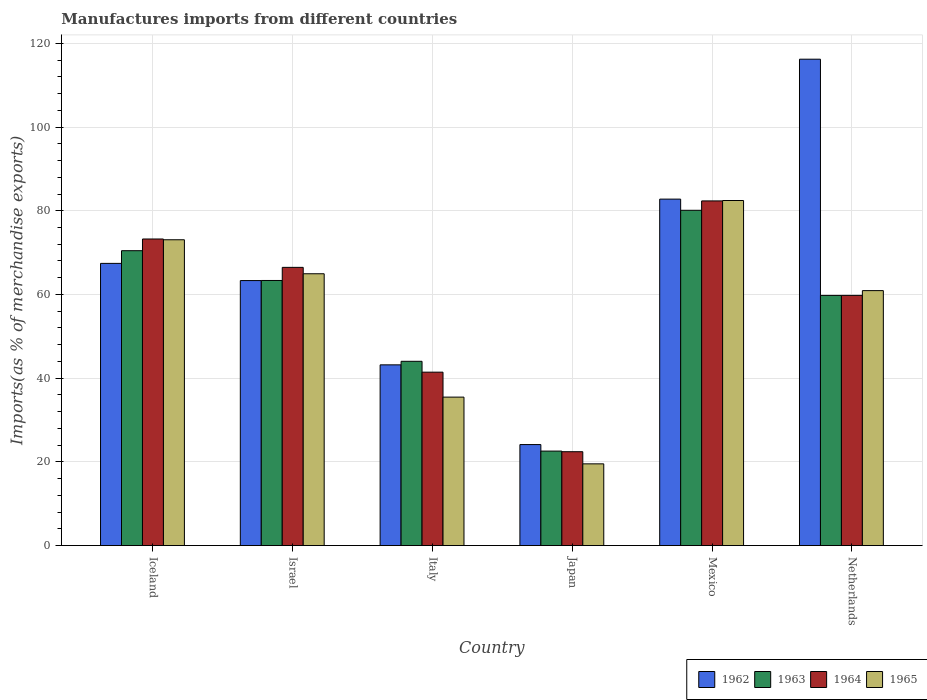How many bars are there on the 2nd tick from the left?
Make the answer very short. 4. In how many cases, is the number of bars for a given country not equal to the number of legend labels?
Your answer should be compact. 0. What is the percentage of imports to different countries in 1964 in Mexico?
Offer a terse response. 82.35. Across all countries, what is the maximum percentage of imports to different countries in 1963?
Provide a short and direct response. 80.11. Across all countries, what is the minimum percentage of imports to different countries in 1964?
Offer a very short reply. 22.43. In which country was the percentage of imports to different countries in 1964 maximum?
Make the answer very short. Mexico. In which country was the percentage of imports to different countries in 1963 minimum?
Your response must be concise. Japan. What is the total percentage of imports to different countries in 1965 in the graph?
Ensure brevity in your answer.  336.36. What is the difference between the percentage of imports to different countries in 1962 in Iceland and that in Israel?
Provide a short and direct response. 4.11. What is the difference between the percentage of imports to different countries in 1963 in Iceland and the percentage of imports to different countries in 1964 in Mexico?
Your answer should be compact. -11.9. What is the average percentage of imports to different countries in 1964 per country?
Offer a very short reply. 57.62. What is the difference between the percentage of imports to different countries of/in 1965 and percentage of imports to different countries of/in 1964 in Netherlands?
Offer a terse response. 1.14. In how many countries, is the percentage of imports to different countries in 1962 greater than 80 %?
Make the answer very short. 2. What is the ratio of the percentage of imports to different countries in 1965 in Iceland to that in Italy?
Make the answer very short. 2.06. Is the percentage of imports to different countries in 1963 in Italy less than that in Mexico?
Provide a succinct answer. Yes. What is the difference between the highest and the second highest percentage of imports to different countries in 1962?
Your answer should be compact. 15.35. What is the difference between the highest and the lowest percentage of imports to different countries in 1962?
Offer a very short reply. 92.08. In how many countries, is the percentage of imports to different countries in 1962 greater than the average percentage of imports to different countries in 1962 taken over all countries?
Give a very brief answer. 3. Is the sum of the percentage of imports to different countries in 1965 in Japan and Mexico greater than the maximum percentage of imports to different countries in 1964 across all countries?
Provide a short and direct response. Yes. What does the 3rd bar from the left in Japan represents?
Ensure brevity in your answer.  1964. What does the 1st bar from the right in Mexico represents?
Offer a terse response. 1965. How many bars are there?
Your answer should be compact. 24. Are all the bars in the graph horizontal?
Your answer should be very brief. No. What is the title of the graph?
Provide a short and direct response. Manufactures imports from different countries. Does "2000" appear as one of the legend labels in the graph?
Your response must be concise. No. What is the label or title of the Y-axis?
Keep it short and to the point. Imports(as % of merchandise exports). What is the Imports(as % of merchandise exports) in 1962 in Iceland?
Make the answer very short. 67.42. What is the Imports(as % of merchandise exports) in 1963 in Iceland?
Make the answer very short. 70.45. What is the Imports(as % of merchandise exports) in 1964 in Iceland?
Offer a very short reply. 73.25. What is the Imports(as % of merchandise exports) of 1965 in Iceland?
Your answer should be compact. 73.07. What is the Imports(as % of merchandise exports) in 1962 in Israel?
Offer a very short reply. 63.32. What is the Imports(as % of merchandise exports) in 1963 in Israel?
Give a very brief answer. 63.34. What is the Imports(as % of merchandise exports) in 1964 in Israel?
Ensure brevity in your answer.  66.47. What is the Imports(as % of merchandise exports) of 1965 in Israel?
Make the answer very short. 64.94. What is the Imports(as % of merchandise exports) of 1962 in Italy?
Provide a succinct answer. 43.18. What is the Imports(as % of merchandise exports) in 1963 in Italy?
Make the answer very short. 44.02. What is the Imports(as % of merchandise exports) in 1964 in Italy?
Make the answer very short. 41.43. What is the Imports(as % of merchandise exports) of 1965 in Italy?
Offer a very short reply. 35.47. What is the Imports(as % of merchandise exports) in 1962 in Japan?
Your response must be concise. 24.13. What is the Imports(as % of merchandise exports) of 1963 in Japan?
Your answer should be compact. 22.57. What is the Imports(as % of merchandise exports) of 1964 in Japan?
Keep it short and to the point. 22.43. What is the Imports(as % of merchandise exports) of 1965 in Japan?
Your answer should be very brief. 19.52. What is the Imports(as % of merchandise exports) in 1962 in Mexico?
Give a very brief answer. 82.78. What is the Imports(as % of merchandise exports) in 1963 in Mexico?
Your answer should be very brief. 80.11. What is the Imports(as % of merchandise exports) in 1964 in Mexico?
Ensure brevity in your answer.  82.35. What is the Imports(as % of merchandise exports) of 1965 in Mexico?
Your response must be concise. 82.44. What is the Imports(as % of merchandise exports) of 1962 in Netherlands?
Offer a very short reply. 116.21. What is the Imports(as % of merchandise exports) of 1963 in Netherlands?
Your response must be concise. 59.77. What is the Imports(as % of merchandise exports) of 1964 in Netherlands?
Your answer should be very brief. 59.78. What is the Imports(as % of merchandise exports) of 1965 in Netherlands?
Offer a terse response. 60.91. Across all countries, what is the maximum Imports(as % of merchandise exports) in 1962?
Keep it short and to the point. 116.21. Across all countries, what is the maximum Imports(as % of merchandise exports) of 1963?
Your response must be concise. 80.11. Across all countries, what is the maximum Imports(as % of merchandise exports) of 1964?
Keep it short and to the point. 82.35. Across all countries, what is the maximum Imports(as % of merchandise exports) of 1965?
Make the answer very short. 82.44. Across all countries, what is the minimum Imports(as % of merchandise exports) of 1962?
Make the answer very short. 24.13. Across all countries, what is the minimum Imports(as % of merchandise exports) of 1963?
Ensure brevity in your answer.  22.57. Across all countries, what is the minimum Imports(as % of merchandise exports) in 1964?
Offer a very short reply. 22.43. Across all countries, what is the minimum Imports(as % of merchandise exports) in 1965?
Make the answer very short. 19.52. What is the total Imports(as % of merchandise exports) in 1962 in the graph?
Keep it short and to the point. 397.04. What is the total Imports(as % of merchandise exports) in 1963 in the graph?
Your response must be concise. 340.27. What is the total Imports(as % of merchandise exports) of 1964 in the graph?
Your response must be concise. 345.71. What is the total Imports(as % of merchandise exports) in 1965 in the graph?
Your response must be concise. 336.36. What is the difference between the Imports(as % of merchandise exports) of 1962 in Iceland and that in Israel?
Your answer should be compact. 4.11. What is the difference between the Imports(as % of merchandise exports) in 1963 in Iceland and that in Israel?
Offer a very short reply. 7.11. What is the difference between the Imports(as % of merchandise exports) in 1964 in Iceland and that in Israel?
Keep it short and to the point. 6.78. What is the difference between the Imports(as % of merchandise exports) of 1965 in Iceland and that in Israel?
Offer a very short reply. 8.12. What is the difference between the Imports(as % of merchandise exports) of 1962 in Iceland and that in Italy?
Provide a short and direct response. 24.24. What is the difference between the Imports(as % of merchandise exports) of 1963 in Iceland and that in Italy?
Provide a succinct answer. 26.43. What is the difference between the Imports(as % of merchandise exports) in 1964 in Iceland and that in Italy?
Provide a short and direct response. 31.82. What is the difference between the Imports(as % of merchandise exports) in 1965 in Iceland and that in Italy?
Provide a short and direct response. 37.6. What is the difference between the Imports(as % of merchandise exports) of 1962 in Iceland and that in Japan?
Keep it short and to the point. 43.29. What is the difference between the Imports(as % of merchandise exports) in 1963 in Iceland and that in Japan?
Your response must be concise. 47.88. What is the difference between the Imports(as % of merchandise exports) in 1964 in Iceland and that in Japan?
Your answer should be compact. 50.82. What is the difference between the Imports(as % of merchandise exports) in 1965 in Iceland and that in Japan?
Provide a succinct answer. 53.54. What is the difference between the Imports(as % of merchandise exports) in 1962 in Iceland and that in Mexico?
Ensure brevity in your answer.  -15.35. What is the difference between the Imports(as % of merchandise exports) in 1963 in Iceland and that in Mexico?
Provide a succinct answer. -9.65. What is the difference between the Imports(as % of merchandise exports) in 1964 in Iceland and that in Mexico?
Give a very brief answer. -9.1. What is the difference between the Imports(as % of merchandise exports) in 1965 in Iceland and that in Mexico?
Make the answer very short. -9.38. What is the difference between the Imports(as % of merchandise exports) in 1962 in Iceland and that in Netherlands?
Give a very brief answer. -48.79. What is the difference between the Imports(as % of merchandise exports) in 1963 in Iceland and that in Netherlands?
Keep it short and to the point. 10.68. What is the difference between the Imports(as % of merchandise exports) in 1964 in Iceland and that in Netherlands?
Your answer should be very brief. 13.47. What is the difference between the Imports(as % of merchandise exports) of 1965 in Iceland and that in Netherlands?
Your answer should be very brief. 12.15. What is the difference between the Imports(as % of merchandise exports) of 1962 in Israel and that in Italy?
Provide a short and direct response. 20.14. What is the difference between the Imports(as % of merchandise exports) of 1963 in Israel and that in Italy?
Make the answer very short. 19.32. What is the difference between the Imports(as % of merchandise exports) of 1964 in Israel and that in Italy?
Your answer should be compact. 25.04. What is the difference between the Imports(as % of merchandise exports) of 1965 in Israel and that in Italy?
Give a very brief answer. 29.47. What is the difference between the Imports(as % of merchandise exports) in 1962 in Israel and that in Japan?
Ensure brevity in your answer.  39.19. What is the difference between the Imports(as % of merchandise exports) in 1963 in Israel and that in Japan?
Offer a very short reply. 40.77. What is the difference between the Imports(as % of merchandise exports) of 1964 in Israel and that in Japan?
Your response must be concise. 44.04. What is the difference between the Imports(as % of merchandise exports) in 1965 in Israel and that in Japan?
Provide a succinct answer. 45.42. What is the difference between the Imports(as % of merchandise exports) of 1962 in Israel and that in Mexico?
Ensure brevity in your answer.  -19.46. What is the difference between the Imports(as % of merchandise exports) of 1963 in Israel and that in Mexico?
Your answer should be very brief. -16.77. What is the difference between the Imports(as % of merchandise exports) in 1964 in Israel and that in Mexico?
Provide a short and direct response. -15.88. What is the difference between the Imports(as % of merchandise exports) in 1965 in Israel and that in Mexico?
Keep it short and to the point. -17.5. What is the difference between the Imports(as % of merchandise exports) in 1962 in Israel and that in Netherlands?
Ensure brevity in your answer.  -52.9. What is the difference between the Imports(as % of merchandise exports) in 1963 in Israel and that in Netherlands?
Provide a short and direct response. 3.57. What is the difference between the Imports(as % of merchandise exports) in 1964 in Israel and that in Netherlands?
Offer a terse response. 6.69. What is the difference between the Imports(as % of merchandise exports) in 1965 in Israel and that in Netherlands?
Your answer should be very brief. 4.03. What is the difference between the Imports(as % of merchandise exports) in 1962 in Italy and that in Japan?
Offer a terse response. 19.05. What is the difference between the Imports(as % of merchandise exports) in 1963 in Italy and that in Japan?
Your answer should be very brief. 21.45. What is the difference between the Imports(as % of merchandise exports) in 1964 in Italy and that in Japan?
Offer a very short reply. 19. What is the difference between the Imports(as % of merchandise exports) in 1965 in Italy and that in Japan?
Offer a terse response. 15.94. What is the difference between the Imports(as % of merchandise exports) in 1962 in Italy and that in Mexico?
Offer a terse response. -39.6. What is the difference between the Imports(as % of merchandise exports) in 1963 in Italy and that in Mexico?
Give a very brief answer. -36.08. What is the difference between the Imports(as % of merchandise exports) in 1964 in Italy and that in Mexico?
Provide a succinct answer. -40.92. What is the difference between the Imports(as % of merchandise exports) of 1965 in Italy and that in Mexico?
Provide a succinct answer. -46.98. What is the difference between the Imports(as % of merchandise exports) of 1962 in Italy and that in Netherlands?
Ensure brevity in your answer.  -73.03. What is the difference between the Imports(as % of merchandise exports) in 1963 in Italy and that in Netherlands?
Your answer should be compact. -15.75. What is the difference between the Imports(as % of merchandise exports) of 1964 in Italy and that in Netherlands?
Provide a succinct answer. -18.35. What is the difference between the Imports(as % of merchandise exports) of 1965 in Italy and that in Netherlands?
Offer a terse response. -25.45. What is the difference between the Imports(as % of merchandise exports) of 1962 in Japan and that in Mexico?
Provide a short and direct response. -58.65. What is the difference between the Imports(as % of merchandise exports) of 1963 in Japan and that in Mexico?
Your response must be concise. -57.53. What is the difference between the Imports(as % of merchandise exports) of 1964 in Japan and that in Mexico?
Your response must be concise. -59.92. What is the difference between the Imports(as % of merchandise exports) in 1965 in Japan and that in Mexico?
Your response must be concise. -62.92. What is the difference between the Imports(as % of merchandise exports) in 1962 in Japan and that in Netherlands?
Make the answer very short. -92.08. What is the difference between the Imports(as % of merchandise exports) of 1963 in Japan and that in Netherlands?
Offer a terse response. -37.2. What is the difference between the Imports(as % of merchandise exports) of 1964 in Japan and that in Netherlands?
Ensure brevity in your answer.  -37.35. What is the difference between the Imports(as % of merchandise exports) of 1965 in Japan and that in Netherlands?
Your answer should be compact. -41.39. What is the difference between the Imports(as % of merchandise exports) of 1962 in Mexico and that in Netherlands?
Provide a succinct answer. -33.43. What is the difference between the Imports(as % of merchandise exports) in 1963 in Mexico and that in Netherlands?
Provide a short and direct response. 20.34. What is the difference between the Imports(as % of merchandise exports) in 1964 in Mexico and that in Netherlands?
Provide a short and direct response. 22.57. What is the difference between the Imports(as % of merchandise exports) of 1965 in Mexico and that in Netherlands?
Offer a terse response. 21.53. What is the difference between the Imports(as % of merchandise exports) of 1962 in Iceland and the Imports(as % of merchandise exports) of 1963 in Israel?
Keep it short and to the point. 4.08. What is the difference between the Imports(as % of merchandise exports) in 1962 in Iceland and the Imports(as % of merchandise exports) in 1964 in Israel?
Give a very brief answer. 0.95. What is the difference between the Imports(as % of merchandise exports) of 1962 in Iceland and the Imports(as % of merchandise exports) of 1965 in Israel?
Provide a succinct answer. 2.48. What is the difference between the Imports(as % of merchandise exports) of 1963 in Iceland and the Imports(as % of merchandise exports) of 1964 in Israel?
Your response must be concise. 3.98. What is the difference between the Imports(as % of merchandise exports) in 1963 in Iceland and the Imports(as % of merchandise exports) in 1965 in Israel?
Give a very brief answer. 5.51. What is the difference between the Imports(as % of merchandise exports) in 1964 in Iceland and the Imports(as % of merchandise exports) in 1965 in Israel?
Offer a very short reply. 8.31. What is the difference between the Imports(as % of merchandise exports) of 1962 in Iceland and the Imports(as % of merchandise exports) of 1963 in Italy?
Your response must be concise. 23.4. What is the difference between the Imports(as % of merchandise exports) of 1962 in Iceland and the Imports(as % of merchandise exports) of 1964 in Italy?
Provide a succinct answer. 25.99. What is the difference between the Imports(as % of merchandise exports) in 1962 in Iceland and the Imports(as % of merchandise exports) in 1965 in Italy?
Offer a terse response. 31.95. What is the difference between the Imports(as % of merchandise exports) of 1963 in Iceland and the Imports(as % of merchandise exports) of 1964 in Italy?
Provide a succinct answer. 29.02. What is the difference between the Imports(as % of merchandise exports) in 1963 in Iceland and the Imports(as % of merchandise exports) in 1965 in Italy?
Ensure brevity in your answer.  34.99. What is the difference between the Imports(as % of merchandise exports) of 1964 in Iceland and the Imports(as % of merchandise exports) of 1965 in Italy?
Your answer should be compact. 37.78. What is the difference between the Imports(as % of merchandise exports) of 1962 in Iceland and the Imports(as % of merchandise exports) of 1963 in Japan?
Your answer should be compact. 44.85. What is the difference between the Imports(as % of merchandise exports) in 1962 in Iceland and the Imports(as % of merchandise exports) in 1964 in Japan?
Offer a very short reply. 45. What is the difference between the Imports(as % of merchandise exports) in 1962 in Iceland and the Imports(as % of merchandise exports) in 1965 in Japan?
Make the answer very short. 47.9. What is the difference between the Imports(as % of merchandise exports) of 1963 in Iceland and the Imports(as % of merchandise exports) of 1964 in Japan?
Your response must be concise. 48.03. What is the difference between the Imports(as % of merchandise exports) in 1963 in Iceland and the Imports(as % of merchandise exports) in 1965 in Japan?
Your answer should be very brief. 50.93. What is the difference between the Imports(as % of merchandise exports) of 1964 in Iceland and the Imports(as % of merchandise exports) of 1965 in Japan?
Provide a succinct answer. 53.73. What is the difference between the Imports(as % of merchandise exports) in 1962 in Iceland and the Imports(as % of merchandise exports) in 1963 in Mexico?
Provide a short and direct response. -12.68. What is the difference between the Imports(as % of merchandise exports) in 1962 in Iceland and the Imports(as % of merchandise exports) in 1964 in Mexico?
Provide a short and direct response. -14.93. What is the difference between the Imports(as % of merchandise exports) of 1962 in Iceland and the Imports(as % of merchandise exports) of 1965 in Mexico?
Keep it short and to the point. -15.02. What is the difference between the Imports(as % of merchandise exports) in 1963 in Iceland and the Imports(as % of merchandise exports) in 1964 in Mexico?
Offer a terse response. -11.9. What is the difference between the Imports(as % of merchandise exports) in 1963 in Iceland and the Imports(as % of merchandise exports) in 1965 in Mexico?
Provide a short and direct response. -11.99. What is the difference between the Imports(as % of merchandise exports) of 1964 in Iceland and the Imports(as % of merchandise exports) of 1965 in Mexico?
Ensure brevity in your answer.  -9.19. What is the difference between the Imports(as % of merchandise exports) in 1962 in Iceland and the Imports(as % of merchandise exports) in 1963 in Netherlands?
Provide a succinct answer. 7.65. What is the difference between the Imports(as % of merchandise exports) in 1962 in Iceland and the Imports(as % of merchandise exports) in 1964 in Netherlands?
Provide a succinct answer. 7.64. What is the difference between the Imports(as % of merchandise exports) in 1962 in Iceland and the Imports(as % of merchandise exports) in 1965 in Netherlands?
Provide a short and direct response. 6.51. What is the difference between the Imports(as % of merchandise exports) of 1963 in Iceland and the Imports(as % of merchandise exports) of 1964 in Netherlands?
Give a very brief answer. 10.68. What is the difference between the Imports(as % of merchandise exports) in 1963 in Iceland and the Imports(as % of merchandise exports) in 1965 in Netherlands?
Ensure brevity in your answer.  9.54. What is the difference between the Imports(as % of merchandise exports) in 1964 in Iceland and the Imports(as % of merchandise exports) in 1965 in Netherlands?
Ensure brevity in your answer.  12.34. What is the difference between the Imports(as % of merchandise exports) in 1962 in Israel and the Imports(as % of merchandise exports) in 1963 in Italy?
Provide a short and direct response. 19.29. What is the difference between the Imports(as % of merchandise exports) in 1962 in Israel and the Imports(as % of merchandise exports) in 1964 in Italy?
Provide a succinct answer. 21.88. What is the difference between the Imports(as % of merchandise exports) of 1962 in Israel and the Imports(as % of merchandise exports) of 1965 in Italy?
Offer a terse response. 27.85. What is the difference between the Imports(as % of merchandise exports) in 1963 in Israel and the Imports(as % of merchandise exports) in 1964 in Italy?
Make the answer very short. 21.91. What is the difference between the Imports(as % of merchandise exports) in 1963 in Israel and the Imports(as % of merchandise exports) in 1965 in Italy?
Keep it short and to the point. 27.87. What is the difference between the Imports(as % of merchandise exports) in 1964 in Israel and the Imports(as % of merchandise exports) in 1965 in Italy?
Provide a succinct answer. 31. What is the difference between the Imports(as % of merchandise exports) in 1962 in Israel and the Imports(as % of merchandise exports) in 1963 in Japan?
Offer a terse response. 40.74. What is the difference between the Imports(as % of merchandise exports) in 1962 in Israel and the Imports(as % of merchandise exports) in 1964 in Japan?
Your answer should be compact. 40.89. What is the difference between the Imports(as % of merchandise exports) of 1962 in Israel and the Imports(as % of merchandise exports) of 1965 in Japan?
Provide a short and direct response. 43.79. What is the difference between the Imports(as % of merchandise exports) in 1963 in Israel and the Imports(as % of merchandise exports) in 1964 in Japan?
Offer a terse response. 40.91. What is the difference between the Imports(as % of merchandise exports) of 1963 in Israel and the Imports(as % of merchandise exports) of 1965 in Japan?
Your response must be concise. 43.82. What is the difference between the Imports(as % of merchandise exports) in 1964 in Israel and the Imports(as % of merchandise exports) in 1965 in Japan?
Keep it short and to the point. 46.94. What is the difference between the Imports(as % of merchandise exports) in 1962 in Israel and the Imports(as % of merchandise exports) in 1963 in Mexico?
Offer a very short reply. -16.79. What is the difference between the Imports(as % of merchandise exports) of 1962 in Israel and the Imports(as % of merchandise exports) of 1964 in Mexico?
Offer a terse response. -19.03. What is the difference between the Imports(as % of merchandise exports) of 1962 in Israel and the Imports(as % of merchandise exports) of 1965 in Mexico?
Offer a terse response. -19.13. What is the difference between the Imports(as % of merchandise exports) in 1963 in Israel and the Imports(as % of merchandise exports) in 1964 in Mexico?
Offer a very short reply. -19.01. What is the difference between the Imports(as % of merchandise exports) in 1963 in Israel and the Imports(as % of merchandise exports) in 1965 in Mexico?
Your answer should be compact. -19.1. What is the difference between the Imports(as % of merchandise exports) of 1964 in Israel and the Imports(as % of merchandise exports) of 1965 in Mexico?
Provide a succinct answer. -15.98. What is the difference between the Imports(as % of merchandise exports) in 1962 in Israel and the Imports(as % of merchandise exports) in 1963 in Netherlands?
Give a very brief answer. 3.54. What is the difference between the Imports(as % of merchandise exports) of 1962 in Israel and the Imports(as % of merchandise exports) of 1964 in Netherlands?
Your response must be concise. 3.54. What is the difference between the Imports(as % of merchandise exports) of 1962 in Israel and the Imports(as % of merchandise exports) of 1965 in Netherlands?
Provide a short and direct response. 2.4. What is the difference between the Imports(as % of merchandise exports) in 1963 in Israel and the Imports(as % of merchandise exports) in 1964 in Netherlands?
Ensure brevity in your answer.  3.56. What is the difference between the Imports(as % of merchandise exports) of 1963 in Israel and the Imports(as % of merchandise exports) of 1965 in Netherlands?
Ensure brevity in your answer.  2.42. What is the difference between the Imports(as % of merchandise exports) in 1964 in Israel and the Imports(as % of merchandise exports) in 1965 in Netherlands?
Your answer should be very brief. 5.55. What is the difference between the Imports(as % of merchandise exports) in 1962 in Italy and the Imports(as % of merchandise exports) in 1963 in Japan?
Offer a very short reply. 20.61. What is the difference between the Imports(as % of merchandise exports) of 1962 in Italy and the Imports(as % of merchandise exports) of 1964 in Japan?
Your answer should be compact. 20.75. What is the difference between the Imports(as % of merchandise exports) of 1962 in Italy and the Imports(as % of merchandise exports) of 1965 in Japan?
Offer a very short reply. 23.66. What is the difference between the Imports(as % of merchandise exports) of 1963 in Italy and the Imports(as % of merchandise exports) of 1964 in Japan?
Keep it short and to the point. 21.6. What is the difference between the Imports(as % of merchandise exports) in 1963 in Italy and the Imports(as % of merchandise exports) in 1965 in Japan?
Your answer should be compact. 24.5. What is the difference between the Imports(as % of merchandise exports) of 1964 in Italy and the Imports(as % of merchandise exports) of 1965 in Japan?
Offer a terse response. 21.91. What is the difference between the Imports(as % of merchandise exports) of 1962 in Italy and the Imports(as % of merchandise exports) of 1963 in Mexico?
Ensure brevity in your answer.  -36.93. What is the difference between the Imports(as % of merchandise exports) in 1962 in Italy and the Imports(as % of merchandise exports) in 1964 in Mexico?
Your response must be concise. -39.17. What is the difference between the Imports(as % of merchandise exports) in 1962 in Italy and the Imports(as % of merchandise exports) in 1965 in Mexico?
Ensure brevity in your answer.  -39.26. What is the difference between the Imports(as % of merchandise exports) of 1963 in Italy and the Imports(as % of merchandise exports) of 1964 in Mexico?
Provide a succinct answer. -38.33. What is the difference between the Imports(as % of merchandise exports) in 1963 in Italy and the Imports(as % of merchandise exports) in 1965 in Mexico?
Ensure brevity in your answer.  -38.42. What is the difference between the Imports(as % of merchandise exports) in 1964 in Italy and the Imports(as % of merchandise exports) in 1965 in Mexico?
Your response must be concise. -41.01. What is the difference between the Imports(as % of merchandise exports) of 1962 in Italy and the Imports(as % of merchandise exports) of 1963 in Netherlands?
Your answer should be compact. -16.59. What is the difference between the Imports(as % of merchandise exports) in 1962 in Italy and the Imports(as % of merchandise exports) in 1964 in Netherlands?
Your answer should be very brief. -16.6. What is the difference between the Imports(as % of merchandise exports) of 1962 in Italy and the Imports(as % of merchandise exports) of 1965 in Netherlands?
Make the answer very short. -17.73. What is the difference between the Imports(as % of merchandise exports) of 1963 in Italy and the Imports(as % of merchandise exports) of 1964 in Netherlands?
Your answer should be compact. -15.75. What is the difference between the Imports(as % of merchandise exports) of 1963 in Italy and the Imports(as % of merchandise exports) of 1965 in Netherlands?
Provide a succinct answer. -16.89. What is the difference between the Imports(as % of merchandise exports) of 1964 in Italy and the Imports(as % of merchandise exports) of 1965 in Netherlands?
Give a very brief answer. -19.48. What is the difference between the Imports(as % of merchandise exports) in 1962 in Japan and the Imports(as % of merchandise exports) in 1963 in Mexico?
Offer a very short reply. -55.98. What is the difference between the Imports(as % of merchandise exports) in 1962 in Japan and the Imports(as % of merchandise exports) in 1964 in Mexico?
Make the answer very short. -58.22. What is the difference between the Imports(as % of merchandise exports) of 1962 in Japan and the Imports(as % of merchandise exports) of 1965 in Mexico?
Give a very brief answer. -58.32. What is the difference between the Imports(as % of merchandise exports) of 1963 in Japan and the Imports(as % of merchandise exports) of 1964 in Mexico?
Offer a terse response. -59.78. What is the difference between the Imports(as % of merchandise exports) in 1963 in Japan and the Imports(as % of merchandise exports) in 1965 in Mexico?
Offer a very short reply. -59.87. What is the difference between the Imports(as % of merchandise exports) of 1964 in Japan and the Imports(as % of merchandise exports) of 1965 in Mexico?
Ensure brevity in your answer.  -60.02. What is the difference between the Imports(as % of merchandise exports) in 1962 in Japan and the Imports(as % of merchandise exports) in 1963 in Netherlands?
Your answer should be compact. -35.64. What is the difference between the Imports(as % of merchandise exports) in 1962 in Japan and the Imports(as % of merchandise exports) in 1964 in Netherlands?
Your answer should be very brief. -35.65. What is the difference between the Imports(as % of merchandise exports) in 1962 in Japan and the Imports(as % of merchandise exports) in 1965 in Netherlands?
Make the answer very short. -36.79. What is the difference between the Imports(as % of merchandise exports) in 1963 in Japan and the Imports(as % of merchandise exports) in 1964 in Netherlands?
Your answer should be very brief. -37.2. What is the difference between the Imports(as % of merchandise exports) in 1963 in Japan and the Imports(as % of merchandise exports) in 1965 in Netherlands?
Ensure brevity in your answer.  -38.34. What is the difference between the Imports(as % of merchandise exports) of 1964 in Japan and the Imports(as % of merchandise exports) of 1965 in Netherlands?
Keep it short and to the point. -38.49. What is the difference between the Imports(as % of merchandise exports) of 1962 in Mexico and the Imports(as % of merchandise exports) of 1963 in Netherlands?
Your response must be concise. 23.01. What is the difference between the Imports(as % of merchandise exports) of 1962 in Mexico and the Imports(as % of merchandise exports) of 1964 in Netherlands?
Make the answer very short. 23. What is the difference between the Imports(as % of merchandise exports) of 1962 in Mexico and the Imports(as % of merchandise exports) of 1965 in Netherlands?
Your response must be concise. 21.86. What is the difference between the Imports(as % of merchandise exports) in 1963 in Mexico and the Imports(as % of merchandise exports) in 1964 in Netherlands?
Your answer should be compact. 20.33. What is the difference between the Imports(as % of merchandise exports) in 1963 in Mexico and the Imports(as % of merchandise exports) in 1965 in Netherlands?
Offer a very short reply. 19.19. What is the difference between the Imports(as % of merchandise exports) of 1964 in Mexico and the Imports(as % of merchandise exports) of 1965 in Netherlands?
Keep it short and to the point. 21.44. What is the average Imports(as % of merchandise exports) of 1962 per country?
Provide a short and direct response. 66.17. What is the average Imports(as % of merchandise exports) in 1963 per country?
Offer a very short reply. 56.71. What is the average Imports(as % of merchandise exports) in 1964 per country?
Make the answer very short. 57.62. What is the average Imports(as % of merchandise exports) in 1965 per country?
Give a very brief answer. 56.06. What is the difference between the Imports(as % of merchandise exports) in 1962 and Imports(as % of merchandise exports) in 1963 in Iceland?
Keep it short and to the point. -3.03. What is the difference between the Imports(as % of merchandise exports) in 1962 and Imports(as % of merchandise exports) in 1964 in Iceland?
Provide a short and direct response. -5.83. What is the difference between the Imports(as % of merchandise exports) of 1962 and Imports(as % of merchandise exports) of 1965 in Iceland?
Provide a short and direct response. -5.64. What is the difference between the Imports(as % of merchandise exports) of 1963 and Imports(as % of merchandise exports) of 1964 in Iceland?
Offer a very short reply. -2.8. What is the difference between the Imports(as % of merchandise exports) in 1963 and Imports(as % of merchandise exports) in 1965 in Iceland?
Keep it short and to the point. -2.61. What is the difference between the Imports(as % of merchandise exports) in 1964 and Imports(as % of merchandise exports) in 1965 in Iceland?
Ensure brevity in your answer.  0.18. What is the difference between the Imports(as % of merchandise exports) in 1962 and Imports(as % of merchandise exports) in 1963 in Israel?
Provide a short and direct response. -0.02. What is the difference between the Imports(as % of merchandise exports) in 1962 and Imports(as % of merchandise exports) in 1964 in Israel?
Offer a very short reply. -3.15. What is the difference between the Imports(as % of merchandise exports) of 1962 and Imports(as % of merchandise exports) of 1965 in Israel?
Offer a terse response. -1.63. What is the difference between the Imports(as % of merchandise exports) in 1963 and Imports(as % of merchandise exports) in 1964 in Israel?
Your response must be concise. -3.13. What is the difference between the Imports(as % of merchandise exports) of 1963 and Imports(as % of merchandise exports) of 1965 in Israel?
Keep it short and to the point. -1.6. What is the difference between the Imports(as % of merchandise exports) in 1964 and Imports(as % of merchandise exports) in 1965 in Israel?
Keep it short and to the point. 1.53. What is the difference between the Imports(as % of merchandise exports) of 1962 and Imports(as % of merchandise exports) of 1963 in Italy?
Give a very brief answer. -0.84. What is the difference between the Imports(as % of merchandise exports) of 1962 and Imports(as % of merchandise exports) of 1964 in Italy?
Keep it short and to the point. 1.75. What is the difference between the Imports(as % of merchandise exports) in 1962 and Imports(as % of merchandise exports) in 1965 in Italy?
Offer a very short reply. 7.71. What is the difference between the Imports(as % of merchandise exports) in 1963 and Imports(as % of merchandise exports) in 1964 in Italy?
Make the answer very short. 2.59. What is the difference between the Imports(as % of merchandise exports) of 1963 and Imports(as % of merchandise exports) of 1965 in Italy?
Make the answer very short. 8.56. What is the difference between the Imports(as % of merchandise exports) of 1964 and Imports(as % of merchandise exports) of 1965 in Italy?
Make the answer very short. 5.96. What is the difference between the Imports(as % of merchandise exports) of 1962 and Imports(as % of merchandise exports) of 1963 in Japan?
Offer a very short reply. 1.55. What is the difference between the Imports(as % of merchandise exports) in 1962 and Imports(as % of merchandise exports) in 1964 in Japan?
Give a very brief answer. 1.7. What is the difference between the Imports(as % of merchandise exports) in 1962 and Imports(as % of merchandise exports) in 1965 in Japan?
Your response must be concise. 4.6. What is the difference between the Imports(as % of merchandise exports) of 1963 and Imports(as % of merchandise exports) of 1964 in Japan?
Provide a short and direct response. 0.15. What is the difference between the Imports(as % of merchandise exports) in 1963 and Imports(as % of merchandise exports) in 1965 in Japan?
Ensure brevity in your answer.  3.05. What is the difference between the Imports(as % of merchandise exports) of 1964 and Imports(as % of merchandise exports) of 1965 in Japan?
Your response must be concise. 2.9. What is the difference between the Imports(as % of merchandise exports) of 1962 and Imports(as % of merchandise exports) of 1963 in Mexico?
Ensure brevity in your answer.  2.67. What is the difference between the Imports(as % of merchandise exports) in 1962 and Imports(as % of merchandise exports) in 1964 in Mexico?
Provide a short and direct response. 0.43. What is the difference between the Imports(as % of merchandise exports) of 1962 and Imports(as % of merchandise exports) of 1965 in Mexico?
Your response must be concise. 0.33. What is the difference between the Imports(as % of merchandise exports) of 1963 and Imports(as % of merchandise exports) of 1964 in Mexico?
Your response must be concise. -2.24. What is the difference between the Imports(as % of merchandise exports) of 1963 and Imports(as % of merchandise exports) of 1965 in Mexico?
Provide a succinct answer. -2.34. What is the difference between the Imports(as % of merchandise exports) of 1964 and Imports(as % of merchandise exports) of 1965 in Mexico?
Make the answer very short. -0.09. What is the difference between the Imports(as % of merchandise exports) in 1962 and Imports(as % of merchandise exports) in 1963 in Netherlands?
Provide a succinct answer. 56.44. What is the difference between the Imports(as % of merchandise exports) in 1962 and Imports(as % of merchandise exports) in 1964 in Netherlands?
Offer a very short reply. 56.43. What is the difference between the Imports(as % of merchandise exports) of 1962 and Imports(as % of merchandise exports) of 1965 in Netherlands?
Your response must be concise. 55.3. What is the difference between the Imports(as % of merchandise exports) of 1963 and Imports(as % of merchandise exports) of 1964 in Netherlands?
Provide a succinct answer. -0.01. What is the difference between the Imports(as % of merchandise exports) of 1963 and Imports(as % of merchandise exports) of 1965 in Netherlands?
Ensure brevity in your answer.  -1.14. What is the difference between the Imports(as % of merchandise exports) in 1964 and Imports(as % of merchandise exports) in 1965 in Netherlands?
Give a very brief answer. -1.14. What is the ratio of the Imports(as % of merchandise exports) in 1962 in Iceland to that in Israel?
Your response must be concise. 1.06. What is the ratio of the Imports(as % of merchandise exports) in 1963 in Iceland to that in Israel?
Keep it short and to the point. 1.11. What is the ratio of the Imports(as % of merchandise exports) in 1964 in Iceland to that in Israel?
Keep it short and to the point. 1.1. What is the ratio of the Imports(as % of merchandise exports) of 1965 in Iceland to that in Israel?
Ensure brevity in your answer.  1.13. What is the ratio of the Imports(as % of merchandise exports) of 1962 in Iceland to that in Italy?
Make the answer very short. 1.56. What is the ratio of the Imports(as % of merchandise exports) in 1963 in Iceland to that in Italy?
Offer a terse response. 1.6. What is the ratio of the Imports(as % of merchandise exports) in 1964 in Iceland to that in Italy?
Give a very brief answer. 1.77. What is the ratio of the Imports(as % of merchandise exports) in 1965 in Iceland to that in Italy?
Ensure brevity in your answer.  2.06. What is the ratio of the Imports(as % of merchandise exports) in 1962 in Iceland to that in Japan?
Keep it short and to the point. 2.79. What is the ratio of the Imports(as % of merchandise exports) in 1963 in Iceland to that in Japan?
Your answer should be very brief. 3.12. What is the ratio of the Imports(as % of merchandise exports) of 1964 in Iceland to that in Japan?
Ensure brevity in your answer.  3.27. What is the ratio of the Imports(as % of merchandise exports) in 1965 in Iceland to that in Japan?
Give a very brief answer. 3.74. What is the ratio of the Imports(as % of merchandise exports) of 1962 in Iceland to that in Mexico?
Provide a short and direct response. 0.81. What is the ratio of the Imports(as % of merchandise exports) in 1963 in Iceland to that in Mexico?
Ensure brevity in your answer.  0.88. What is the ratio of the Imports(as % of merchandise exports) in 1964 in Iceland to that in Mexico?
Your answer should be very brief. 0.89. What is the ratio of the Imports(as % of merchandise exports) in 1965 in Iceland to that in Mexico?
Provide a succinct answer. 0.89. What is the ratio of the Imports(as % of merchandise exports) of 1962 in Iceland to that in Netherlands?
Make the answer very short. 0.58. What is the ratio of the Imports(as % of merchandise exports) of 1963 in Iceland to that in Netherlands?
Make the answer very short. 1.18. What is the ratio of the Imports(as % of merchandise exports) in 1964 in Iceland to that in Netherlands?
Provide a short and direct response. 1.23. What is the ratio of the Imports(as % of merchandise exports) in 1965 in Iceland to that in Netherlands?
Provide a succinct answer. 1.2. What is the ratio of the Imports(as % of merchandise exports) in 1962 in Israel to that in Italy?
Keep it short and to the point. 1.47. What is the ratio of the Imports(as % of merchandise exports) of 1963 in Israel to that in Italy?
Ensure brevity in your answer.  1.44. What is the ratio of the Imports(as % of merchandise exports) in 1964 in Israel to that in Italy?
Your answer should be compact. 1.6. What is the ratio of the Imports(as % of merchandise exports) in 1965 in Israel to that in Italy?
Provide a succinct answer. 1.83. What is the ratio of the Imports(as % of merchandise exports) of 1962 in Israel to that in Japan?
Provide a succinct answer. 2.62. What is the ratio of the Imports(as % of merchandise exports) of 1963 in Israel to that in Japan?
Provide a succinct answer. 2.81. What is the ratio of the Imports(as % of merchandise exports) of 1964 in Israel to that in Japan?
Your answer should be compact. 2.96. What is the ratio of the Imports(as % of merchandise exports) of 1965 in Israel to that in Japan?
Offer a very short reply. 3.33. What is the ratio of the Imports(as % of merchandise exports) of 1962 in Israel to that in Mexico?
Your response must be concise. 0.76. What is the ratio of the Imports(as % of merchandise exports) of 1963 in Israel to that in Mexico?
Keep it short and to the point. 0.79. What is the ratio of the Imports(as % of merchandise exports) of 1964 in Israel to that in Mexico?
Your answer should be compact. 0.81. What is the ratio of the Imports(as % of merchandise exports) of 1965 in Israel to that in Mexico?
Provide a short and direct response. 0.79. What is the ratio of the Imports(as % of merchandise exports) in 1962 in Israel to that in Netherlands?
Offer a very short reply. 0.54. What is the ratio of the Imports(as % of merchandise exports) in 1963 in Israel to that in Netherlands?
Offer a very short reply. 1.06. What is the ratio of the Imports(as % of merchandise exports) of 1964 in Israel to that in Netherlands?
Offer a very short reply. 1.11. What is the ratio of the Imports(as % of merchandise exports) of 1965 in Israel to that in Netherlands?
Provide a short and direct response. 1.07. What is the ratio of the Imports(as % of merchandise exports) in 1962 in Italy to that in Japan?
Offer a terse response. 1.79. What is the ratio of the Imports(as % of merchandise exports) of 1963 in Italy to that in Japan?
Make the answer very short. 1.95. What is the ratio of the Imports(as % of merchandise exports) of 1964 in Italy to that in Japan?
Keep it short and to the point. 1.85. What is the ratio of the Imports(as % of merchandise exports) in 1965 in Italy to that in Japan?
Offer a terse response. 1.82. What is the ratio of the Imports(as % of merchandise exports) in 1962 in Italy to that in Mexico?
Ensure brevity in your answer.  0.52. What is the ratio of the Imports(as % of merchandise exports) of 1963 in Italy to that in Mexico?
Keep it short and to the point. 0.55. What is the ratio of the Imports(as % of merchandise exports) in 1964 in Italy to that in Mexico?
Provide a succinct answer. 0.5. What is the ratio of the Imports(as % of merchandise exports) in 1965 in Italy to that in Mexico?
Offer a terse response. 0.43. What is the ratio of the Imports(as % of merchandise exports) in 1962 in Italy to that in Netherlands?
Ensure brevity in your answer.  0.37. What is the ratio of the Imports(as % of merchandise exports) in 1963 in Italy to that in Netherlands?
Make the answer very short. 0.74. What is the ratio of the Imports(as % of merchandise exports) in 1964 in Italy to that in Netherlands?
Keep it short and to the point. 0.69. What is the ratio of the Imports(as % of merchandise exports) in 1965 in Italy to that in Netherlands?
Provide a short and direct response. 0.58. What is the ratio of the Imports(as % of merchandise exports) in 1962 in Japan to that in Mexico?
Provide a succinct answer. 0.29. What is the ratio of the Imports(as % of merchandise exports) in 1963 in Japan to that in Mexico?
Offer a terse response. 0.28. What is the ratio of the Imports(as % of merchandise exports) in 1964 in Japan to that in Mexico?
Your response must be concise. 0.27. What is the ratio of the Imports(as % of merchandise exports) in 1965 in Japan to that in Mexico?
Your answer should be very brief. 0.24. What is the ratio of the Imports(as % of merchandise exports) of 1962 in Japan to that in Netherlands?
Offer a very short reply. 0.21. What is the ratio of the Imports(as % of merchandise exports) in 1963 in Japan to that in Netherlands?
Your answer should be very brief. 0.38. What is the ratio of the Imports(as % of merchandise exports) in 1964 in Japan to that in Netherlands?
Your answer should be very brief. 0.38. What is the ratio of the Imports(as % of merchandise exports) in 1965 in Japan to that in Netherlands?
Your response must be concise. 0.32. What is the ratio of the Imports(as % of merchandise exports) in 1962 in Mexico to that in Netherlands?
Offer a terse response. 0.71. What is the ratio of the Imports(as % of merchandise exports) in 1963 in Mexico to that in Netherlands?
Your answer should be compact. 1.34. What is the ratio of the Imports(as % of merchandise exports) in 1964 in Mexico to that in Netherlands?
Make the answer very short. 1.38. What is the ratio of the Imports(as % of merchandise exports) in 1965 in Mexico to that in Netherlands?
Your answer should be compact. 1.35. What is the difference between the highest and the second highest Imports(as % of merchandise exports) of 1962?
Keep it short and to the point. 33.43. What is the difference between the highest and the second highest Imports(as % of merchandise exports) in 1963?
Offer a very short reply. 9.65. What is the difference between the highest and the second highest Imports(as % of merchandise exports) of 1964?
Your answer should be compact. 9.1. What is the difference between the highest and the second highest Imports(as % of merchandise exports) in 1965?
Give a very brief answer. 9.38. What is the difference between the highest and the lowest Imports(as % of merchandise exports) in 1962?
Your answer should be compact. 92.08. What is the difference between the highest and the lowest Imports(as % of merchandise exports) of 1963?
Your answer should be compact. 57.53. What is the difference between the highest and the lowest Imports(as % of merchandise exports) in 1964?
Keep it short and to the point. 59.92. What is the difference between the highest and the lowest Imports(as % of merchandise exports) of 1965?
Offer a very short reply. 62.92. 